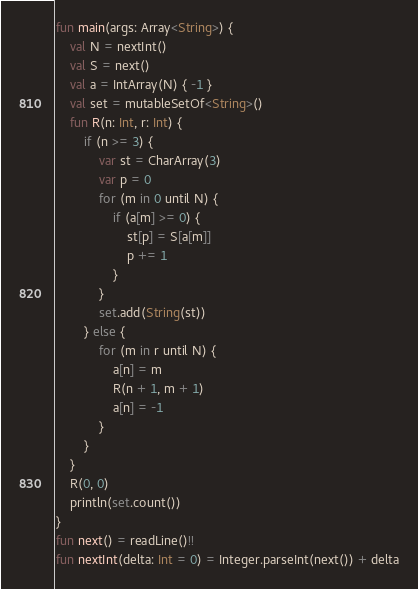Convert code to text. <code><loc_0><loc_0><loc_500><loc_500><_Kotlin_>fun main(args: Array<String>) {
    val N = nextInt()
    val S = next()
    val a = IntArray(N) { -1 }
    val set = mutableSetOf<String>()
    fun R(n: Int, r: Int) {
        if (n >= 3) {
            var st = CharArray(3)
            var p = 0
            for (m in 0 until N) {
                if (a[m] >= 0) {
                    st[p] = S[a[m]]
                    p += 1
                }
            }
            set.add(String(st))
        } else {
            for (m in r until N) {
                a[n] = m
                R(n + 1, m + 1)
                a[n] = -1
            }
        }
    }
    R(0, 0)
    println(set.count())
}
fun next() = readLine()!!
fun nextInt(delta: Int = 0) = Integer.parseInt(next()) + delta</code> 